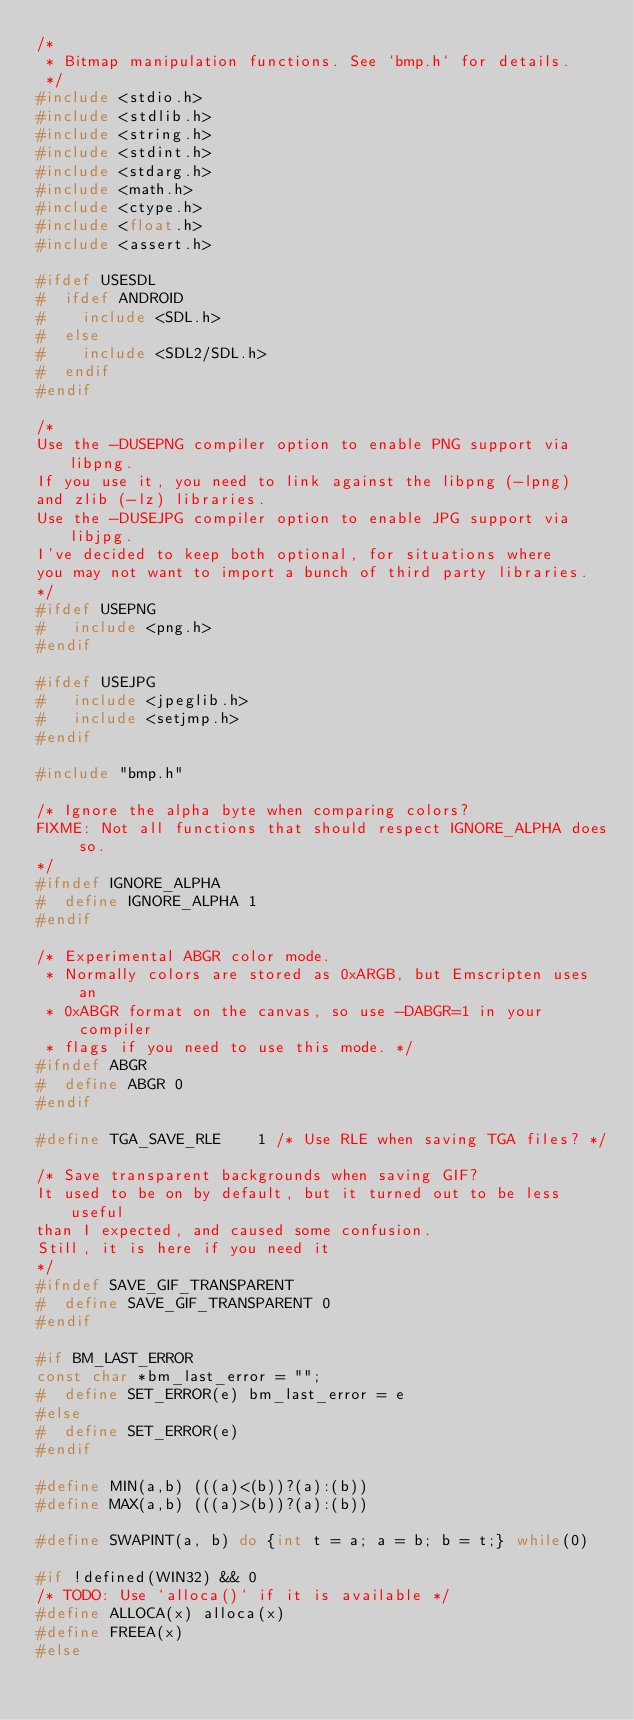<code> <loc_0><loc_0><loc_500><loc_500><_C_>/*
 * Bitmap manipulation functions. See `bmp.h` for details.
 */
#include <stdio.h>
#include <stdlib.h>
#include <string.h>
#include <stdint.h>
#include <stdarg.h>
#include <math.h>
#include <ctype.h>
#include <float.h>
#include <assert.h>

#ifdef USESDL
#  ifdef ANDROID
#    include <SDL.h>
#  else
#    include <SDL2/SDL.h>
#  endif
#endif

/*
Use the -DUSEPNG compiler option to enable PNG support via libpng.
If you use it, you need to link against the libpng (-lpng)
and zlib (-lz) libraries.
Use the -DUSEJPG compiler option to enable JPG support via libjpg.
I've decided to keep both optional, for situations where
you may not want to import a bunch of third party libraries.
*/
#ifdef USEPNG
#   include <png.h>
#endif

#ifdef USEJPG
#   include <jpeglib.h>
#   include <setjmp.h>
#endif

#include "bmp.h"

/* Ignore the alpha byte when comparing colors?
FIXME: Not all functions that should respect IGNORE_ALPHA does so.
*/
#ifndef IGNORE_ALPHA
#  define IGNORE_ALPHA 1
#endif

/* Experimental ABGR color mode.
 * Normally colors are stored as 0xARGB, but Emscripten uses an
 * 0xABGR format on the canvas, so use -DABGR=1 in your compiler
 * flags if you need to use this mode. */
#ifndef ABGR
#  define ABGR 0
#endif

#define TGA_SAVE_RLE    1 /* Use RLE when saving TGA files? */

/* Save transparent backgrounds when saving GIF?
It used to be on by default, but it turned out to be less useful
than I expected, and caused some confusion.
Still, it is here if you need it
*/
#ifndef SAVE_GIF_TRANSPARENT
#  define SAVE_GIF_TRANSPARENT 0
#endif

#if BM_LAST_ERROR
const char *bm_last_error = "";
#  define SET_ERROR(e) bm_last_error = e
#else
#  define SET_ERROR(e)
#endif

#define MIN(a,b) (((a)<(b))?(a):(b))
#define MAX(a,b) (((a)>(b))?(a):(b))

#define SWAPINT(a, b) do {int t = a; a = b; b = t;} while(0)

#if !defined(WIN32) && 0
/* TODO: Use `alloca()` if it is available */
#define ALLOCA(x) alloca(x)
#define FREEA(x)
#else</code> 